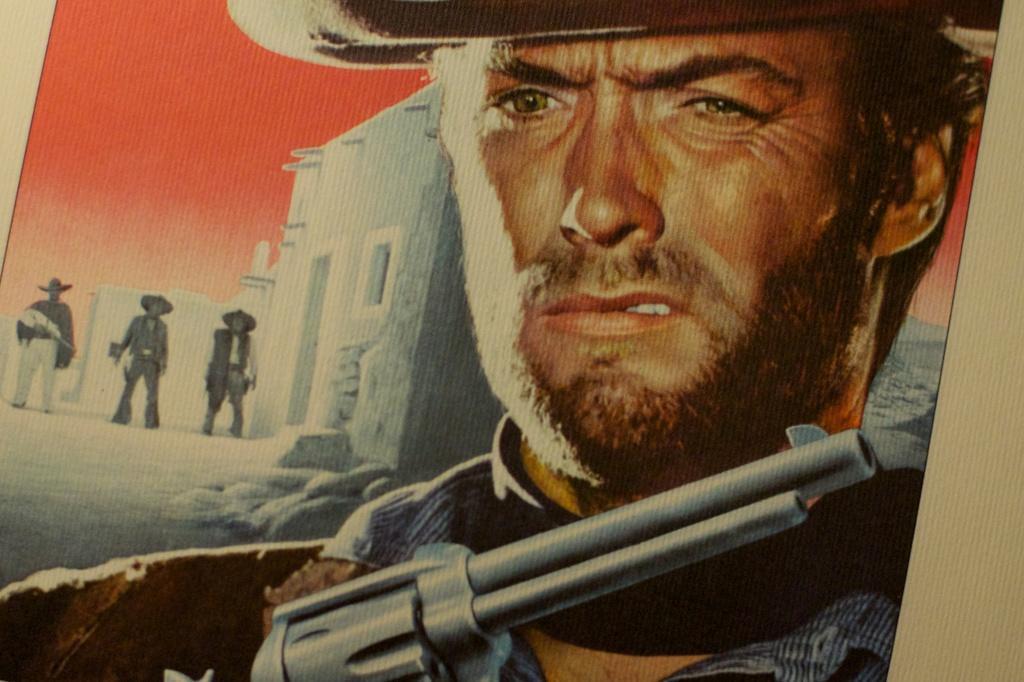Please provide a concise description of this image. In this image I can see a poster in front, on which I can see a man holding a gun and in the background I can see few buildings and 3 persons standing. 